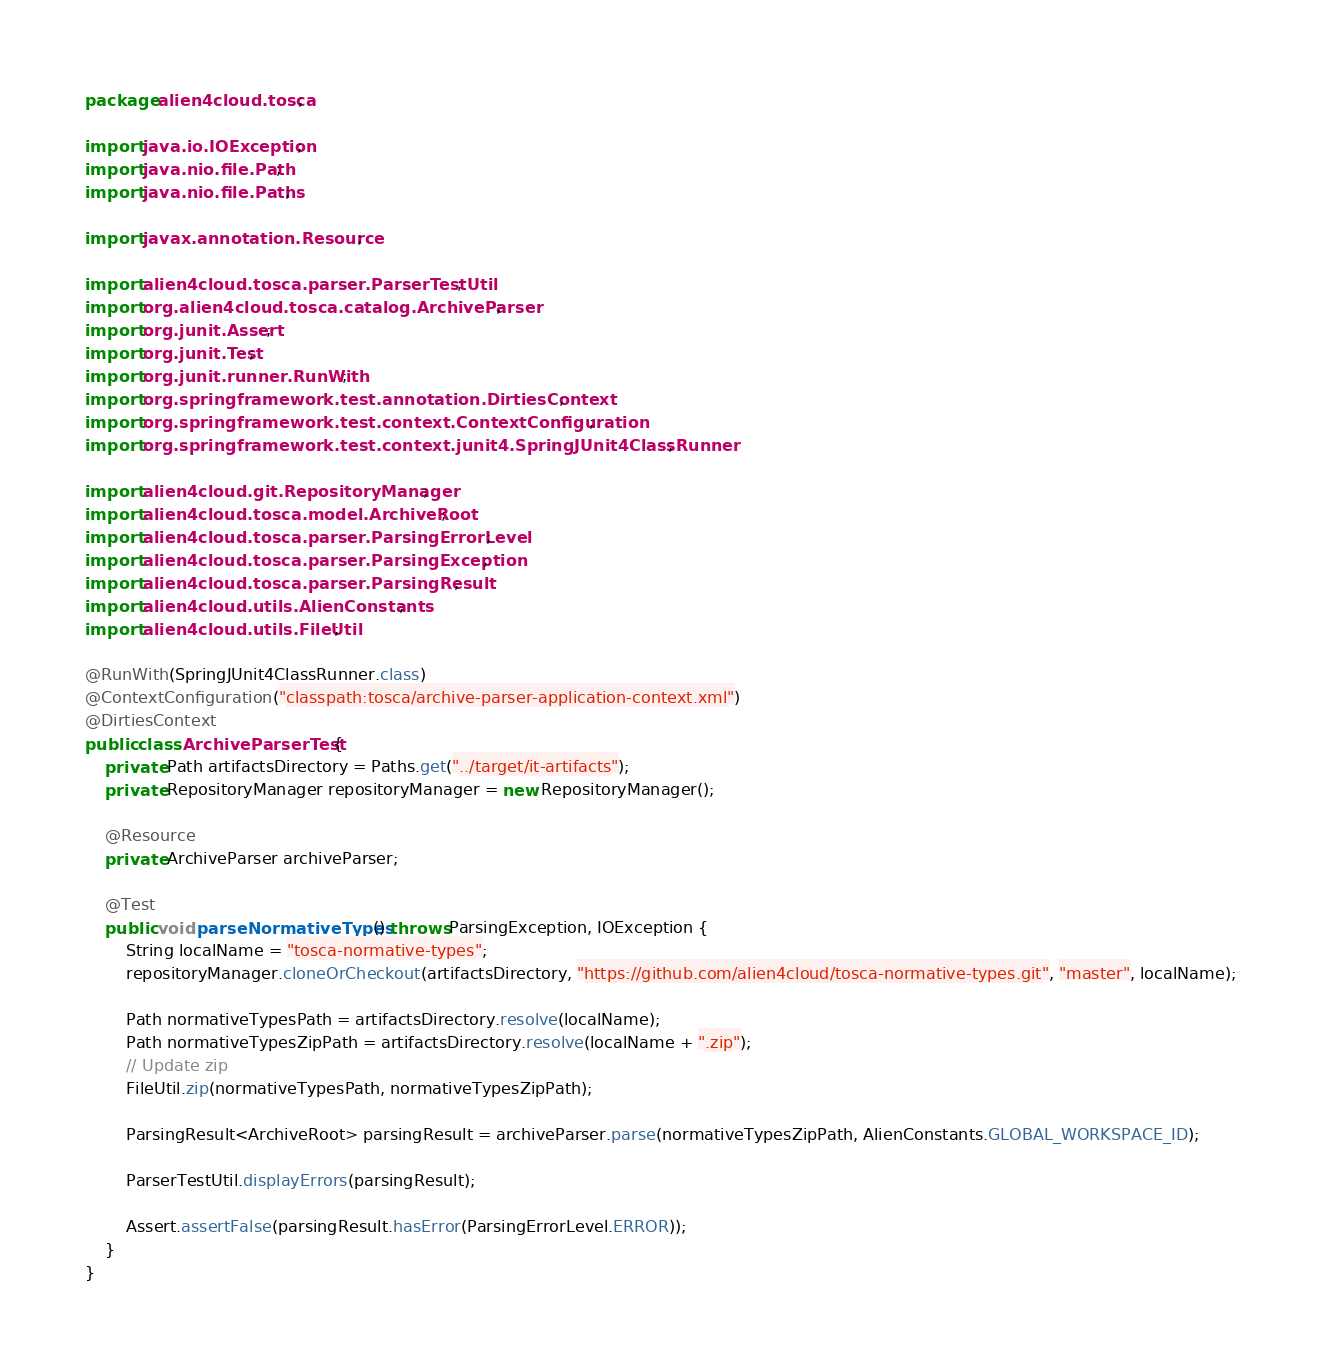Convert code to text. <code><loc_0><loc_0><loc_500><loc_500><_Java_>package alien4cloud.tosca;

import java.io.IOException;
import java.nio.file.Path;
import java.nio.file.Paths;

import javax.annotation.Resource;

import alien4cloud.tosca.parser.ParserTestUtil;
import org.alien4cloud.tosca.catalog.ArchiveParser;
import org.junit.Assert;
import org.junit.Test;
import org.junit.runner.RunWith;
import org.springframework.test.annotation.DirtiesContext;
import org.springframework.test.context.ContextConfiguration;
import org.springframework.test.context.junit4.SpringJUnit4ClassRunner;

import alien4cloud.git.RepositoryManager;
import alien4cloud.tosca.model.ArchiveRoot;
import alien4cloud.tosca.parser.ParsingErrorLevel;
import alien4cloud.tosca.parser.ParsingException;
import alien4cloud.tosca.parser.ParsingResult;
import alien4cloud.utils.AlienConstants;
import alien4cloud.utils.FileUtil;

@RunWith(SpringJUnit4ClassRunner.class)
@ContextConfiguration("classpath:tosca/archive-parser-application-context.xml")
@DirtiesContext
public class ArchiveParserTest {
    private Path artifactsDirectory = Paths.get("../target/it-artifacts");
    private RepositoryManager repositoryManager = new RepositoryManager();

    @Resource
    private ArchiveParser archiveParser;

    @Test
    public void parseNormativeTypes() throws ParsingException, IOException {
        String localName = "tosca-normative-types";
        repositoryManager.cloneOrCheckout(artifactsDirectory, "https://github.com/alien4cloud/tosca-normative-types.git", "master", localName);

        Path normativeTypesPath = artifactsDirectory.resolve(localName);
        Path normativeTypesZipPath = artifactsDirectory.resolve(localName + ".zip");
        // Update zip
        FileUtil.zip(normativeTypesPath, normativeTypesZipPath);

        ParsingResult<ArchiveRoot> parsingResult = archiveParser.parse(normativeTypesZipPath, AlienConstants.GLOBAL_WORKSPACE_ID);

        ParserTestUtil.displayErrors(parsingResult);

        Assert.assertFalse(parsingResult.hasError(ParsingErrorLevel.ERROR));
    }
}
</code> 